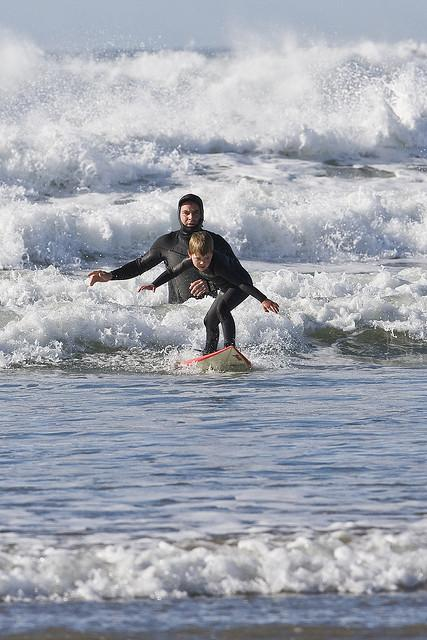Why are they dressed in black?

Choices:
A) fashionable
B) lack money
C) easier spotting
D) wetsuits wetsuits 